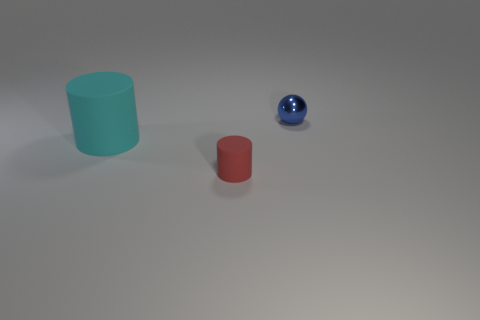What could the relative sizes of these objects suggest if this were a metaphor? If we interpret the scene metaphorically, the relative sizes of these objects could suggest a hierarchy or a progression. The small red object might represent a beginning stage, the blue sphere an intermediate state requiring reflection, and the large turquoise cylinder as a final, more substantial or completed phase. 